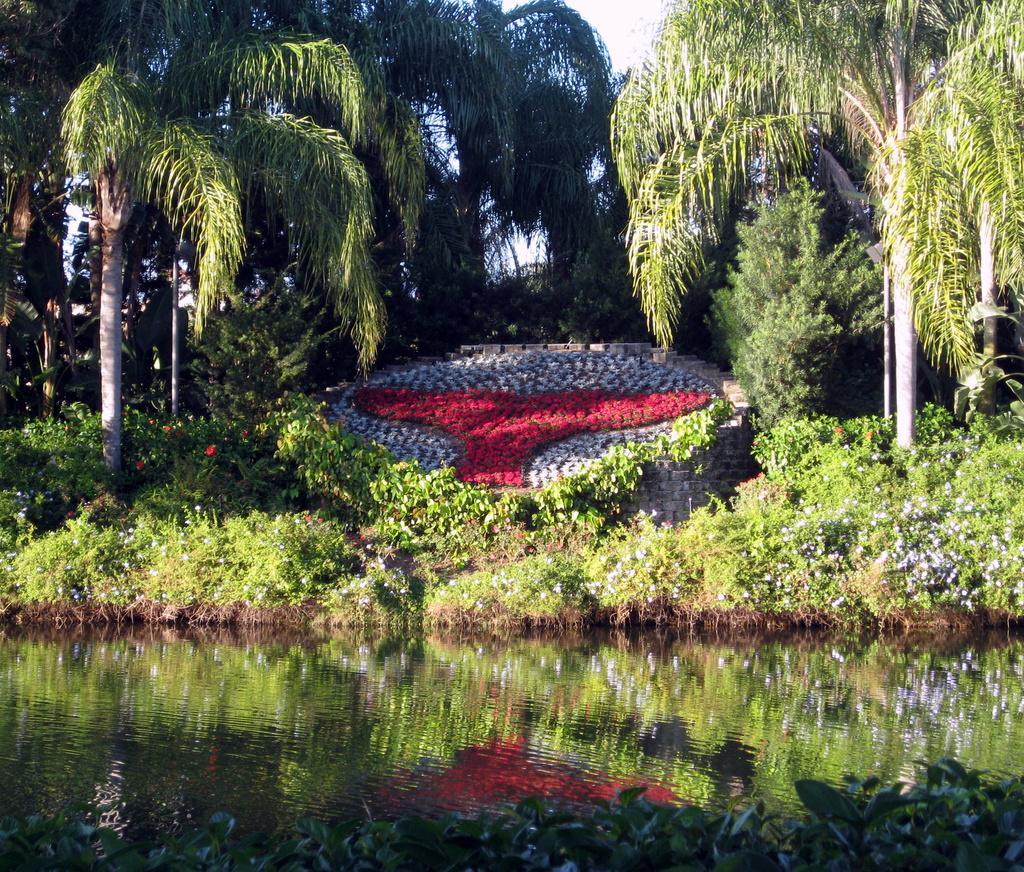In one or two sentences, can you explain what this image depicts? In this image there is the sky towards the top of the image, there are trees towards the top of the image, there is a wall, there are flowers, there is water, there are plants towards the bottom of the image. 